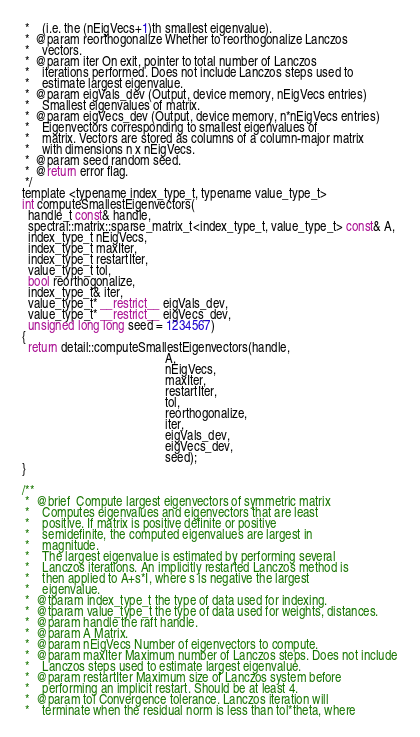<code> <loc_0><loc_0><loc_500><loc_500><_Cuda_> *    (i.e. the (nEigVecs+1)th smallest eigenvalue).
 *  @param reorthogonalize Whether to reorthogonalize Lanczos
 *    vectors.
 *  @param iter On exit, pointer to total number of Lanczos
 *    iterations performed. Does not include Lanczos steps used to
 *    estimate largest eigenvalue.
 *  @param eigVals_dev (Output, device memory, nEigVecs entries)
 *    Smallest eigenvalues of matrix.
 *  @param eigVecs_dev (Output, device memory, n*nEigVecs entries)
 *    Eigenvectors corresponding to smallest eigenvalues of
 *    matrix. Vectors are stored as columns of a column-major matrix
 *    with dimensions n x nEigVecs.
 *  @param seed random seed.
 *  @return error flag.
 */
template <typename index_type_t, typename value_type_t>
int computeSmallestEigenvectors(
  handle_t const& handle,
  spectral::matrix::sparse_matrix_t<index_type_t, value_type_t> const& A,
  index_type_t nEigVecs,
  index_type_t maxIter,
  index_type_t restartIter,
  value_type_t tol,
  bool reorthogonalize,
  index_type_t& iter,
  value_type_t* __restrict__ eigVals_dev,
  value_type_t* __restrict__ eigVecs_dev,
  unsigned long long seed = 1234567)
{
  return detail::computeSmallestEigenvectors(handle,
                                             A,
                                             nEigVecs,
                                             maxIter,
                                             restartIter,
                                             tol,
                                             reorthogonalize,
                                             iter,
                                             eigVals_dev,
                                             eigVecs_dev,
                                             seed);
}

/**
 *  @brief  Compute largest eigenvectors of symmetric matrix
 *    Computes eigenvalues and eigenvectors that are least
 *    positive. If matrix is positive definite or positive
 *    semidefinite, the computed eigenvalues are largest in
 *    magnitude.
 *    The largest eigenvalue is estimated by performing several
 *    Lanczos iterations. An implicitly restarted Lanczos method is
 *    then applied to A+s*I, where s is negative the largest
 *    eigenvalue.
 *  @tparam index_type_t the type of data used for indexing.
 *  @tparam value_type_t the type of data used for weights, distances.
 *  @param handle the raft handle.
 *  @param A Matrix.
 *  @param nEigVecs Number of eigenvectors to compute.
 *  @param maxIter Maximum number of Lanczos steps. Does not include
 *    Lanczos steps used to estimate largest eigenvalue.
 *  @param restartIter Maximum size of Lanczos system before
 *    performing an implicit restart. Should be at least 4.
 *  @param tol Convergence tolerance. Lanczos iteration will
 *    terminate when the residual norm is less than tol*theta, where</code> 